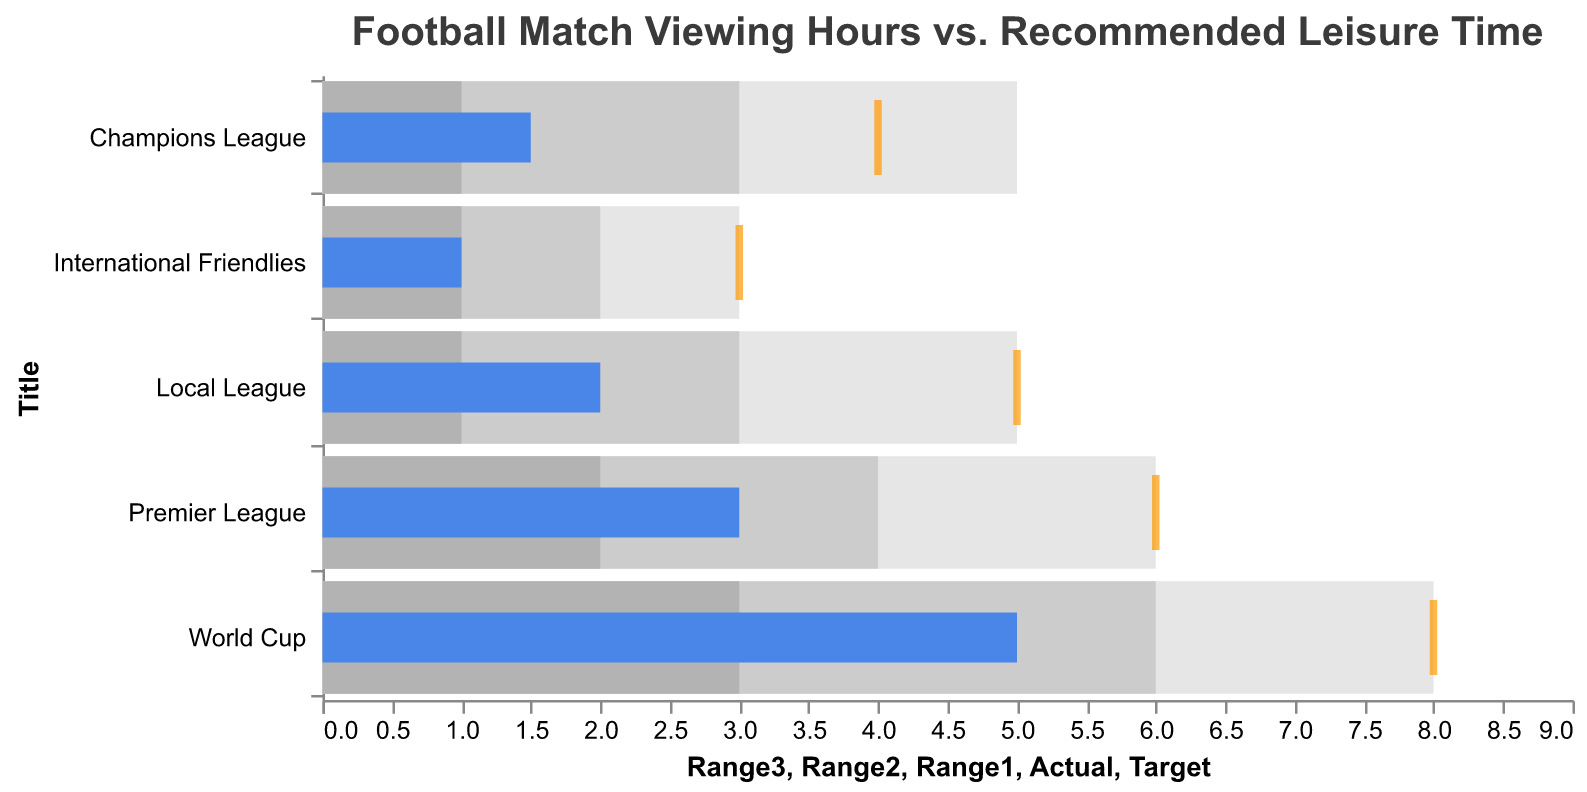What is the actual viewing time for the Premier League? The blue bar corresponding to the Premier League shows an actual viewing time of 3 hours.
Answer: 3 hours Which football event has the highest target viewing time? The orange tick representing the target is the farthest to the right for the World Cup, indicating the highest target viewing time of 8 hours.
Answer: World Cup How does the actual viewing time of the Champions League compare to its target time? The blue bar for the Champions League shows an actual viewing time of 1.5 hours, whereas the orange tick indicates a target of 4 hours. Therefore, the actual viewing time is 2.5 hours less than the target.
Answer: 2.5 hours less Which football event meets its recommended leisure time? By observing the alignment of the blue bar (actual time) with the color ranges, the International Friendlies' actual time (1 hour) is within its recommended leisure time range (1 to 3 hours).
Answer: International Friendlies What is the gap between the actual and target viewing times for the Local League? The actual viewing time for the Local League is 2 hours (blue bar), while the target is 5 hours (orange tick). The gap is 5 - 2 = 3 hours.
Answer: 3 hours How many football events have an actual viewing time that falls within their recommended leisure time (Range3)? We examine the blue bars and their position relative to the shaded Range3 areas. The World Cup and International Friendlies have actual viewing times within their respective Range3.
Answer: 2 events Which football event has the smallest recommended leisure time (Range1)? The Range1 indicator, the smallest shaded area, is lowest for the Local League and International Friendlies, both showing 1 hour.
Answer: Local League and International Friendlies What is the total of the target viewing times across all events? Add up all the target times: 6 (Premier League) + 4 (Champions League) + 8 (World Cup) + 5 (Local League) + 3 (International Friendlies) = 26 hours.
Answer: 26 hours How does the actual viewing time of the World Cup compare to the Local League? The World Cup has an actual viewing time of 5 hours, while the Local League has 2 hours. Therefore, the World Cup's actual viewing time is 3 hours more than the Local League.
Answer: 3 hours more Which football event is the closest to meeting its target viewing time based on actual viewing time? By comparing the distance between each blue bar and its corresponding orange tick, the Premier League's actual viewing time (3 hours) is closest to its target (6 hours) with a gap of 3 hours.
Answer: Premier League 